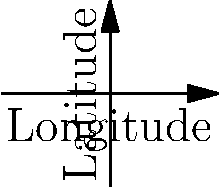As a social media strategist for an online museum, you're analyzing a heat map of visitor locations. The map shows concentric rings of different colors radiating from the museum's location. Which area should you target for a geo-targeted social media campaign to maximize potential new visitors? To answer this question, we need to analyze the heat map and understand its implications:

1. The heat map shows concentric rings of different colors radiating from the museum's location (marked by a dot).
2. In heat maps, colors typically represent the density or frequency of occurrences. In this case, it represents the concentration of visitors.
3. The colors range from red (innermost ring) to blue (outermost ring).
4. In general, red indicates areas of highest concentration, while blue represents areas of lowest concentration.
5. As a social media strategist, the goal is to increase visibility and attract new visitors.
6. Targeting areas with the highest concentration (red) might not be as effective, as these people are already likely to be aware of the museum.
7. Targeting areas with the lowest concentration (blue) might be too far removed from the museum's core audience.
8. The optimal strategy would be to target the area just outside the current high-concentration zones.
9. This area is represented by the green ring in the heat map.
10. By targeting the green area, you can reach people who are geographically close enough to visit but may not be as aware of the museum as those in the red and orange zones.

Therefore, to maximize potential new visitors, you should target the area represented by the green ring in the heat map.
Answer: Green ring area 